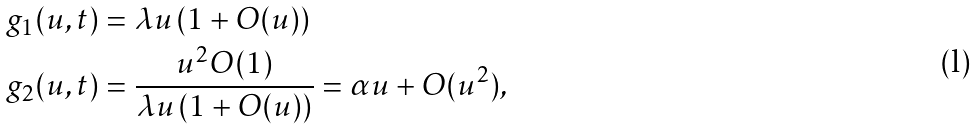<formula> <loc_0><loc_0><loc_500><loc_500>g _ { 1 } ( u , t ) & = \lambda u \left ( 1 + O ( u ) \right ) \\ g _ { 2 } ( u , t ) & = \frac { u ^ { 2 } O ( 1 ) } { \lambda u \left ( 1 + O ( u ) \right ) } = \alpha u + O ( u ^ { 2 } ) ,</formula> 